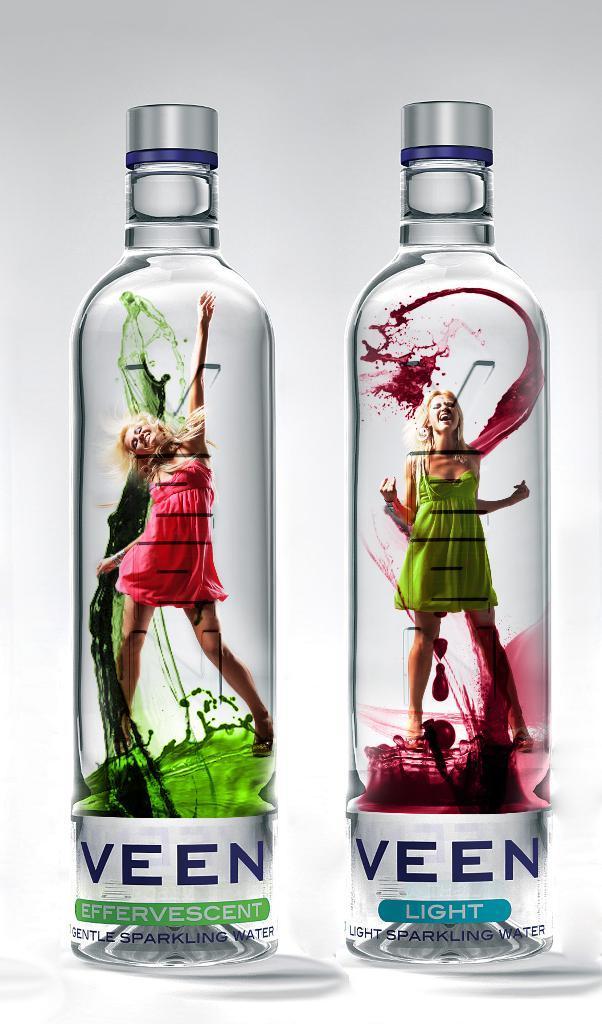Can you describe this image briefly? In this image I can see two bottles and I can see photos of women on it. 